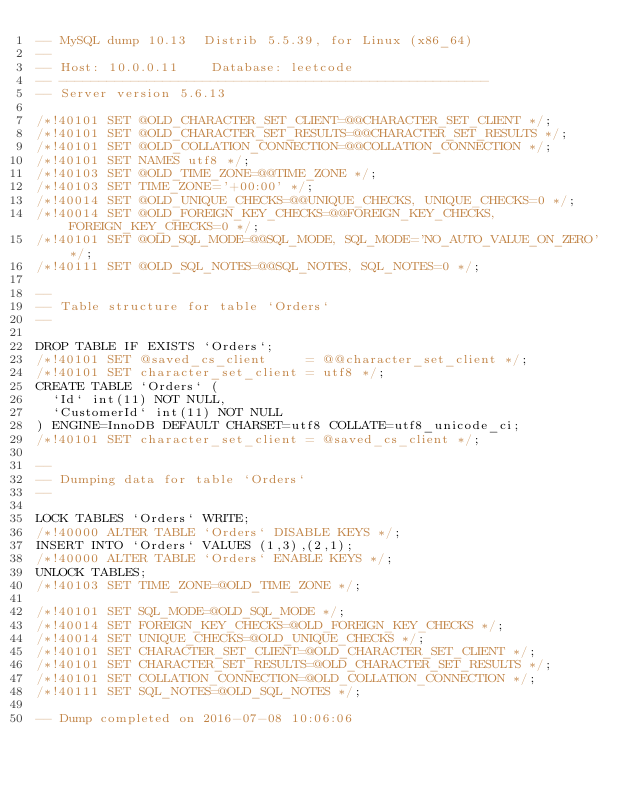Convert code to text. <code><loc_0><loc_0><loc_500><loc_500><_SQL_>-- MySQL dump 10.13  Distrib 5.5.39, for Linux (x86_64)
--
-- Host: 10.0.0.11    Database: leetcode
-- ------------------------------------------------------
-- Server version	5.6.13

/*!40101 SET @OLD_CHARACTER_SET_CLIENT=@@CHARACTER_SET_CLIENT */;
/*!40101 SET @OLD_CHARACTER_SET_RESULTS=@@CHARACTER_SET_RESULTS */;
/*!40101 SET @OLD_COLLATION_CONNECTION=@@COLLATION_CONNECTION */;
/*!40101 SET NAMES utf8 */;
/*!40103 SET @OLD_TIME_ZONE=@@TIME_ZONE */;
/*!40103 SET TIME_ZONE='+00:00' */;
/*!40014 SET @OLD_UNIQUE_CHECKS=@@UNIQUE_CHECKS, UNIQUE_CHECKS=0 */;
/*!40014 SET @OLD_FOREIGN_KEY_CHECKS=@@FOREIGN_KEY_CHECKS, FOREIGN_KEY_CHECKS=0 */;
/*!40101 SET @OLD_SQL_MODE=@@SQL_MODE, SQL_MODE='NO_AUTO_VALUE_ON_ZERO' */;
/*!40111 SET @OLD_SQL_NOTES=@@SQL_NOTES, SQL_NOTES=0 */;

--
-- Table structure for table `Orders`
--

DROP TABLE IF EXISTS `Orders`;
/*!40101 SET @saved_cs_client     = @@character_set_client */;
/*!40101 SET character_set_client = utf8 */;
CREATE TABLE `Orders` (
  `Id` int(11) NOT NULL,
  `CustomerId` int(11) NOT NULL
) ENGINE=InnoDB DEFAULT CHARSET=utf8 COLLATE=utf8_unicode_ci;
/*!40101 SET character_set_client = @saved_cs_client */;

--
-- Dumping data for table `Orders`
--

LOCK TABLES `Orders` WRITE;
/*!40000 ALTER TABLE `Orders` DISABLE KEYS */;
INSERT INTO `Orders` VALUES (1,3),(2,1);
/*!40000 ALTER TABLE `Orders` ENABLE KEYS */;
UNLOCK TABLES;
/*!40103 SET TIME_ZONE=@OLD_TIME_ZONE */;

/*!40101 SET SQL_MODE=@OLD_SQL_MODE */;
/*!40014 SET FOREIGN_KEY_CHECKS=@OLD_FOREIGN_KEY_CHECKS */;
/*!40014 SET UNIQUE_CHECKS=@OLD_UNIQUE_CHECKS */;
/*!40101 SET CHARACTER_SET_CLIENT=@OLD_CHARACTER_SET_CLIENT */;
/*!40101 SET CHARACTER_SET_RESULTS=@OLD_CHARACTER_SET_RESULTS */;
/*!40101 SET COLLATION_CONNECTION=@OLD_COLLATION_CONNECTION */;
/*!40111 SET SQL_NOTES=@OLD_SQL_NOTES */;

-- Dump completed on 2016-07-08 10:06:06
</code> 